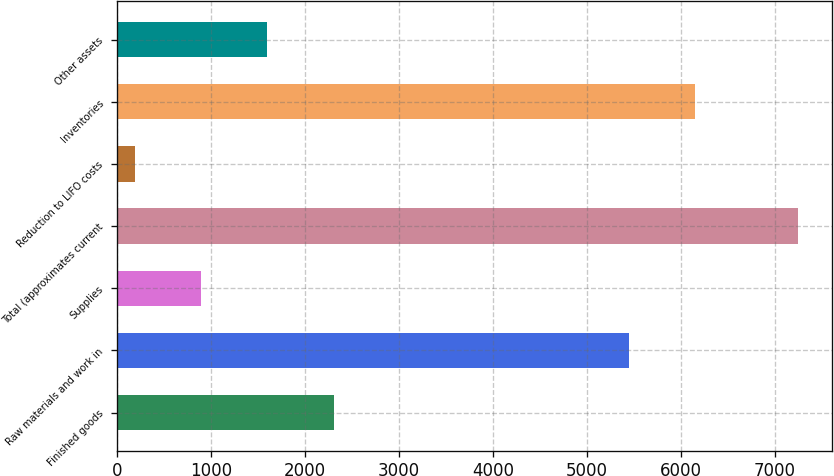<chart> <loc_0><loc_0><loc_500><loc_500><bar_chart><fcel>Finished goods<fcel>Raw materials and work in<fcel>Supplies<fcel>Total (approximates current<fcel>Reduction to LIFO costs<fcel>Inventories<fcel>Other assets<nl><fcel>2304.6<fcel>5449<fcel>892.2<fcel>7248<fcel>186<fcel>6155.2<fcel>1598.4<nl></chart> 